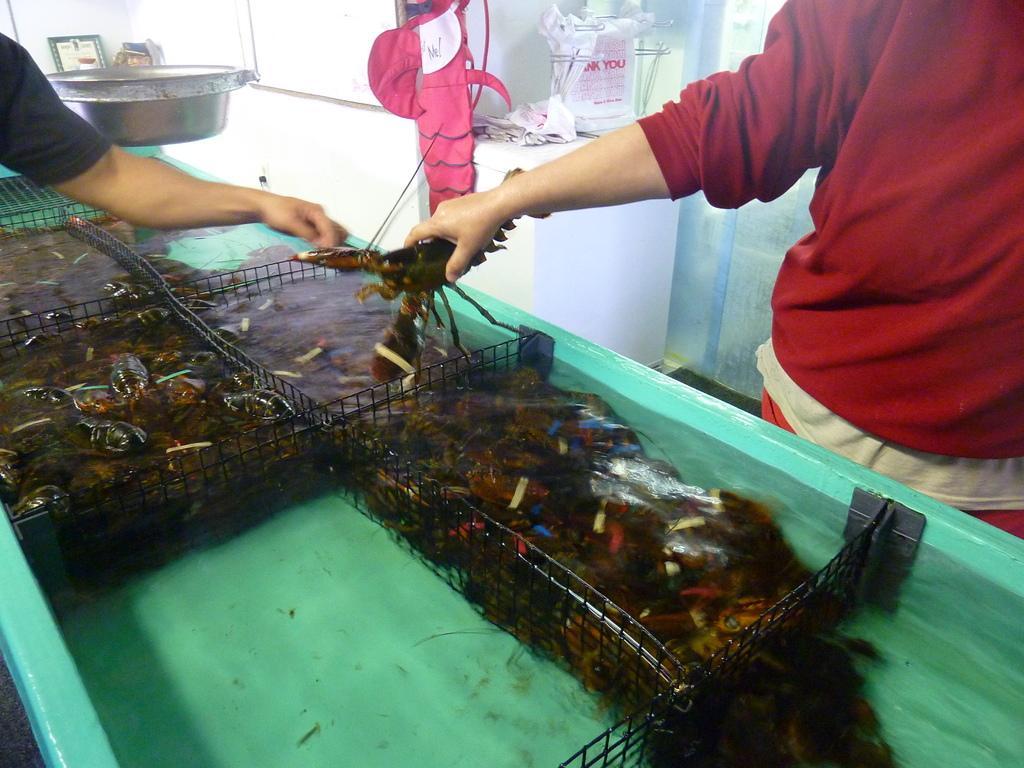Can you describe this image briefly? On the right there is a woman who is wearing t-shirt and trouser. She is standing near to the table. On the top left corner we can see a man's hand who is wearing black t-shirt. Both of them are holding this scorpion. In this blue color table we can see many scorpions, fish, water and this black steel. On the top we can see the cloth, plastic covers, papers and wash basin near to the window. 